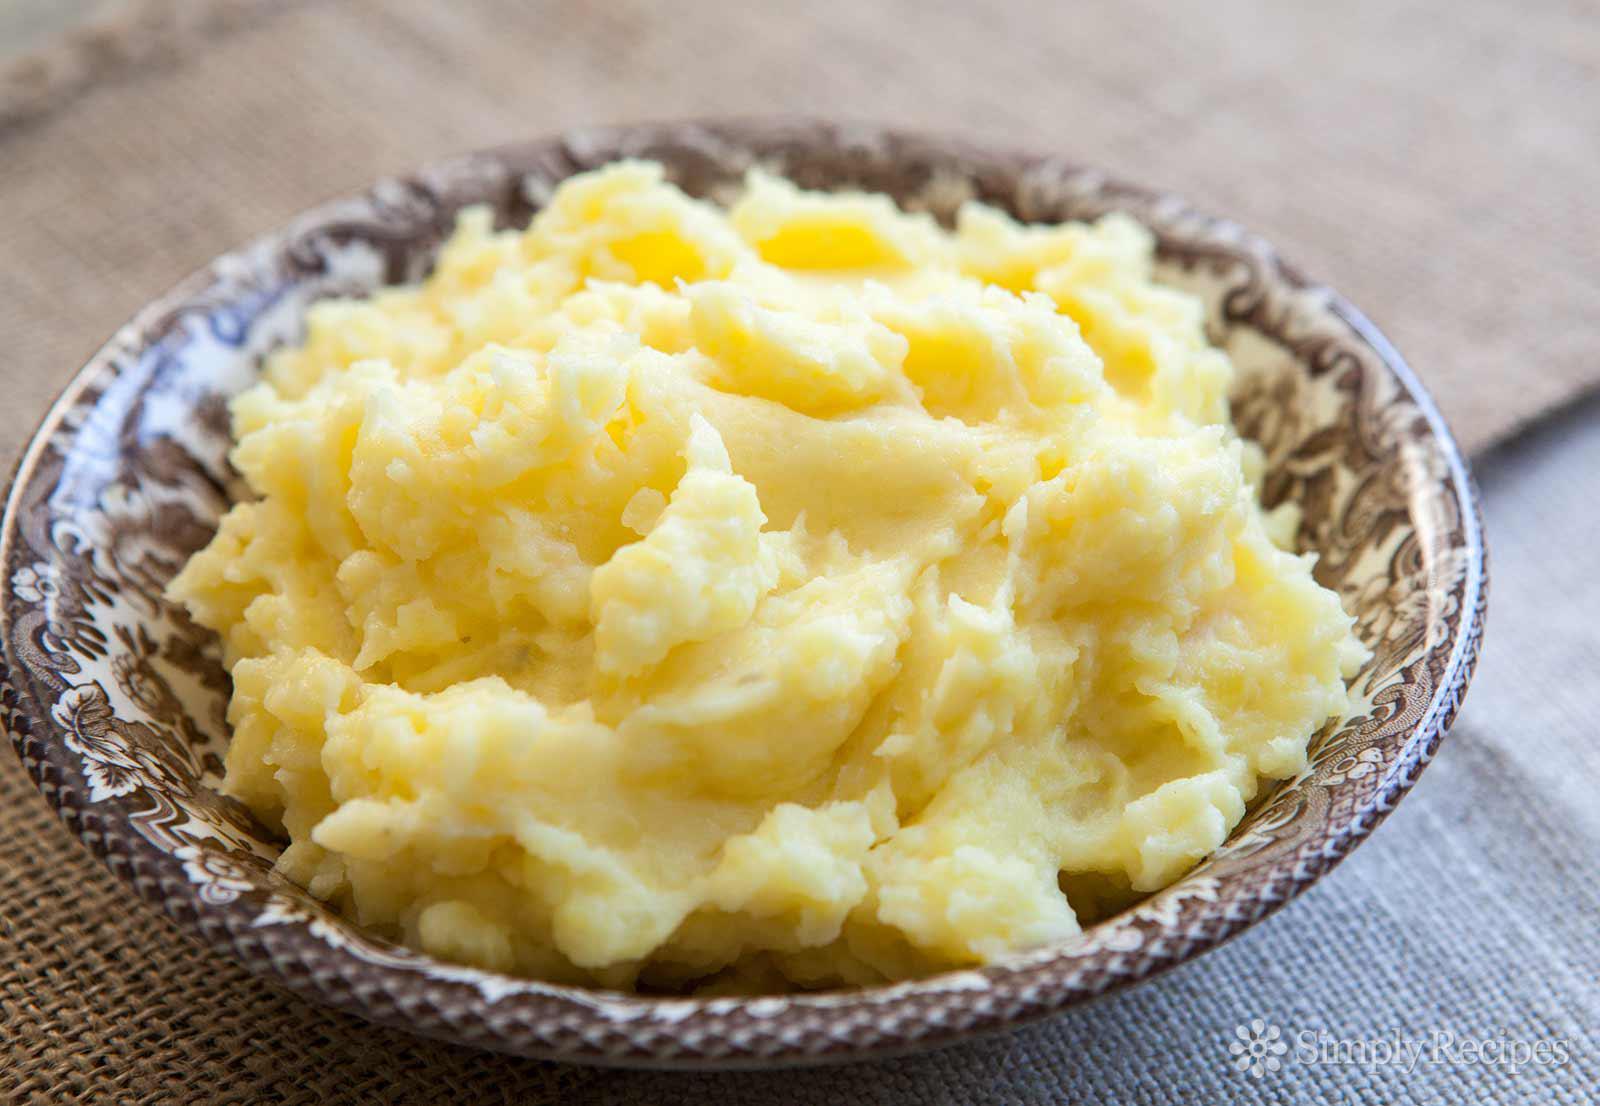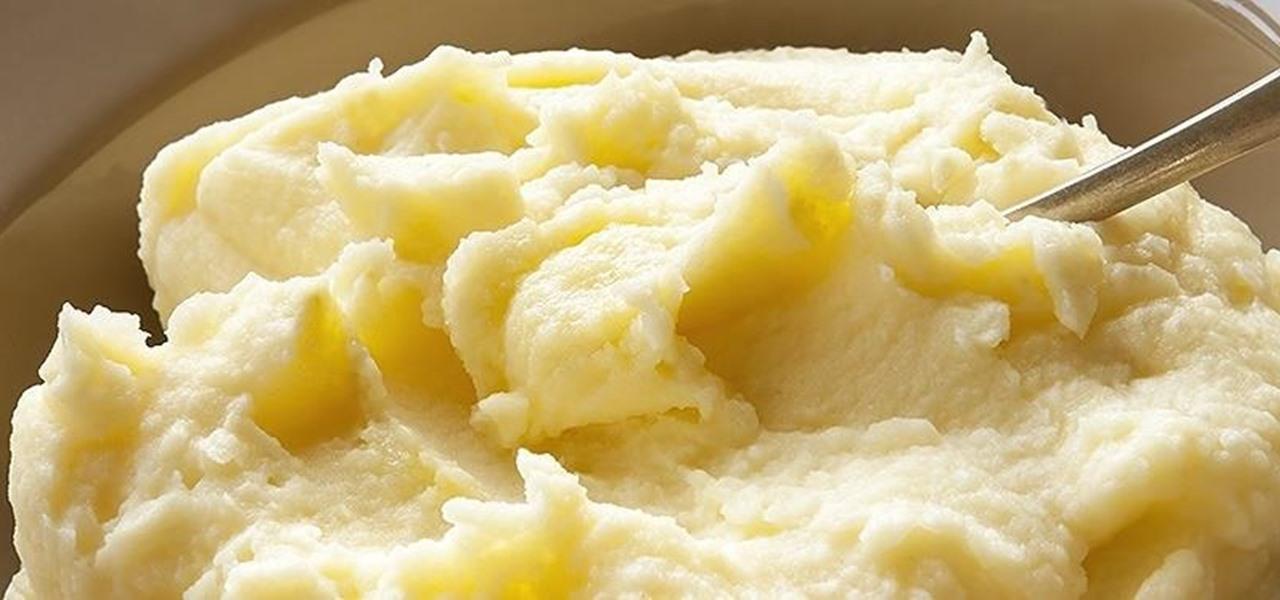The first image is the image on the left, the second image is the image on the right. Assess this claim about the two images: "There is a spoon in the food on the right, but not on the left.". Correct or not? Answer yes or no. Yes. 